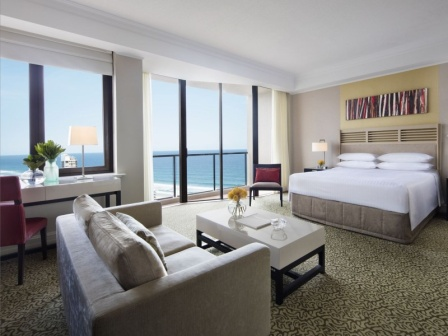How might a business traveler use this room differently from a couple on vacation? A business traveler might primarily use the desk area by the window to work, benefiting from the natural light and scenic views to boost productivity. The comfortable bed provides a restful sleep after a long day of meetings. The balcony serves as a space for quick breaks to clear the mind.

In contrast, a couple on vacation would likely spend more time lounging on the gray sofa or red armchair, enjoying each other’s company. They might have breakfast on the balcony while taking in the ocean view, and use the room as a cozy retreat after exploring the surrounding area. 